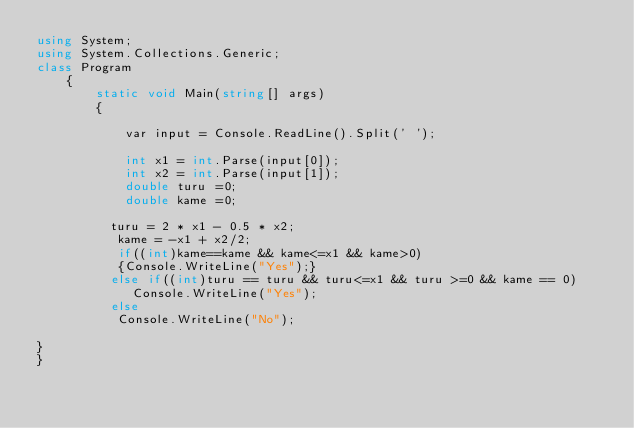Convert code to text. <code><loc_0><loc_0><loc_500><loc_500><_C#_>using System;
using System.Collections.Generic;
class Program
    {
        static void Main(string[] args)
        {

            var input = Console.ReadLine().Split(' ');

            int x1 = int.Parse(input[0]);
            int x2 = int.Parse(input[1]);
            double turu =0;
            double kame =0;
 
          turu = 2 * x1 - 0.5 * x2;  
           kame = -x1 + x2/2;
           if((int)kame==kame && kame<=x1 && kame>0)
           {Console.WriteLine("Yes");}
          else if((int)turu == turu && turu<=x1 && turu >=0 && kame == 0)
             Console.WriteLine("Yes");
          else
           Console.WriteLine("No");

}
}</code> 